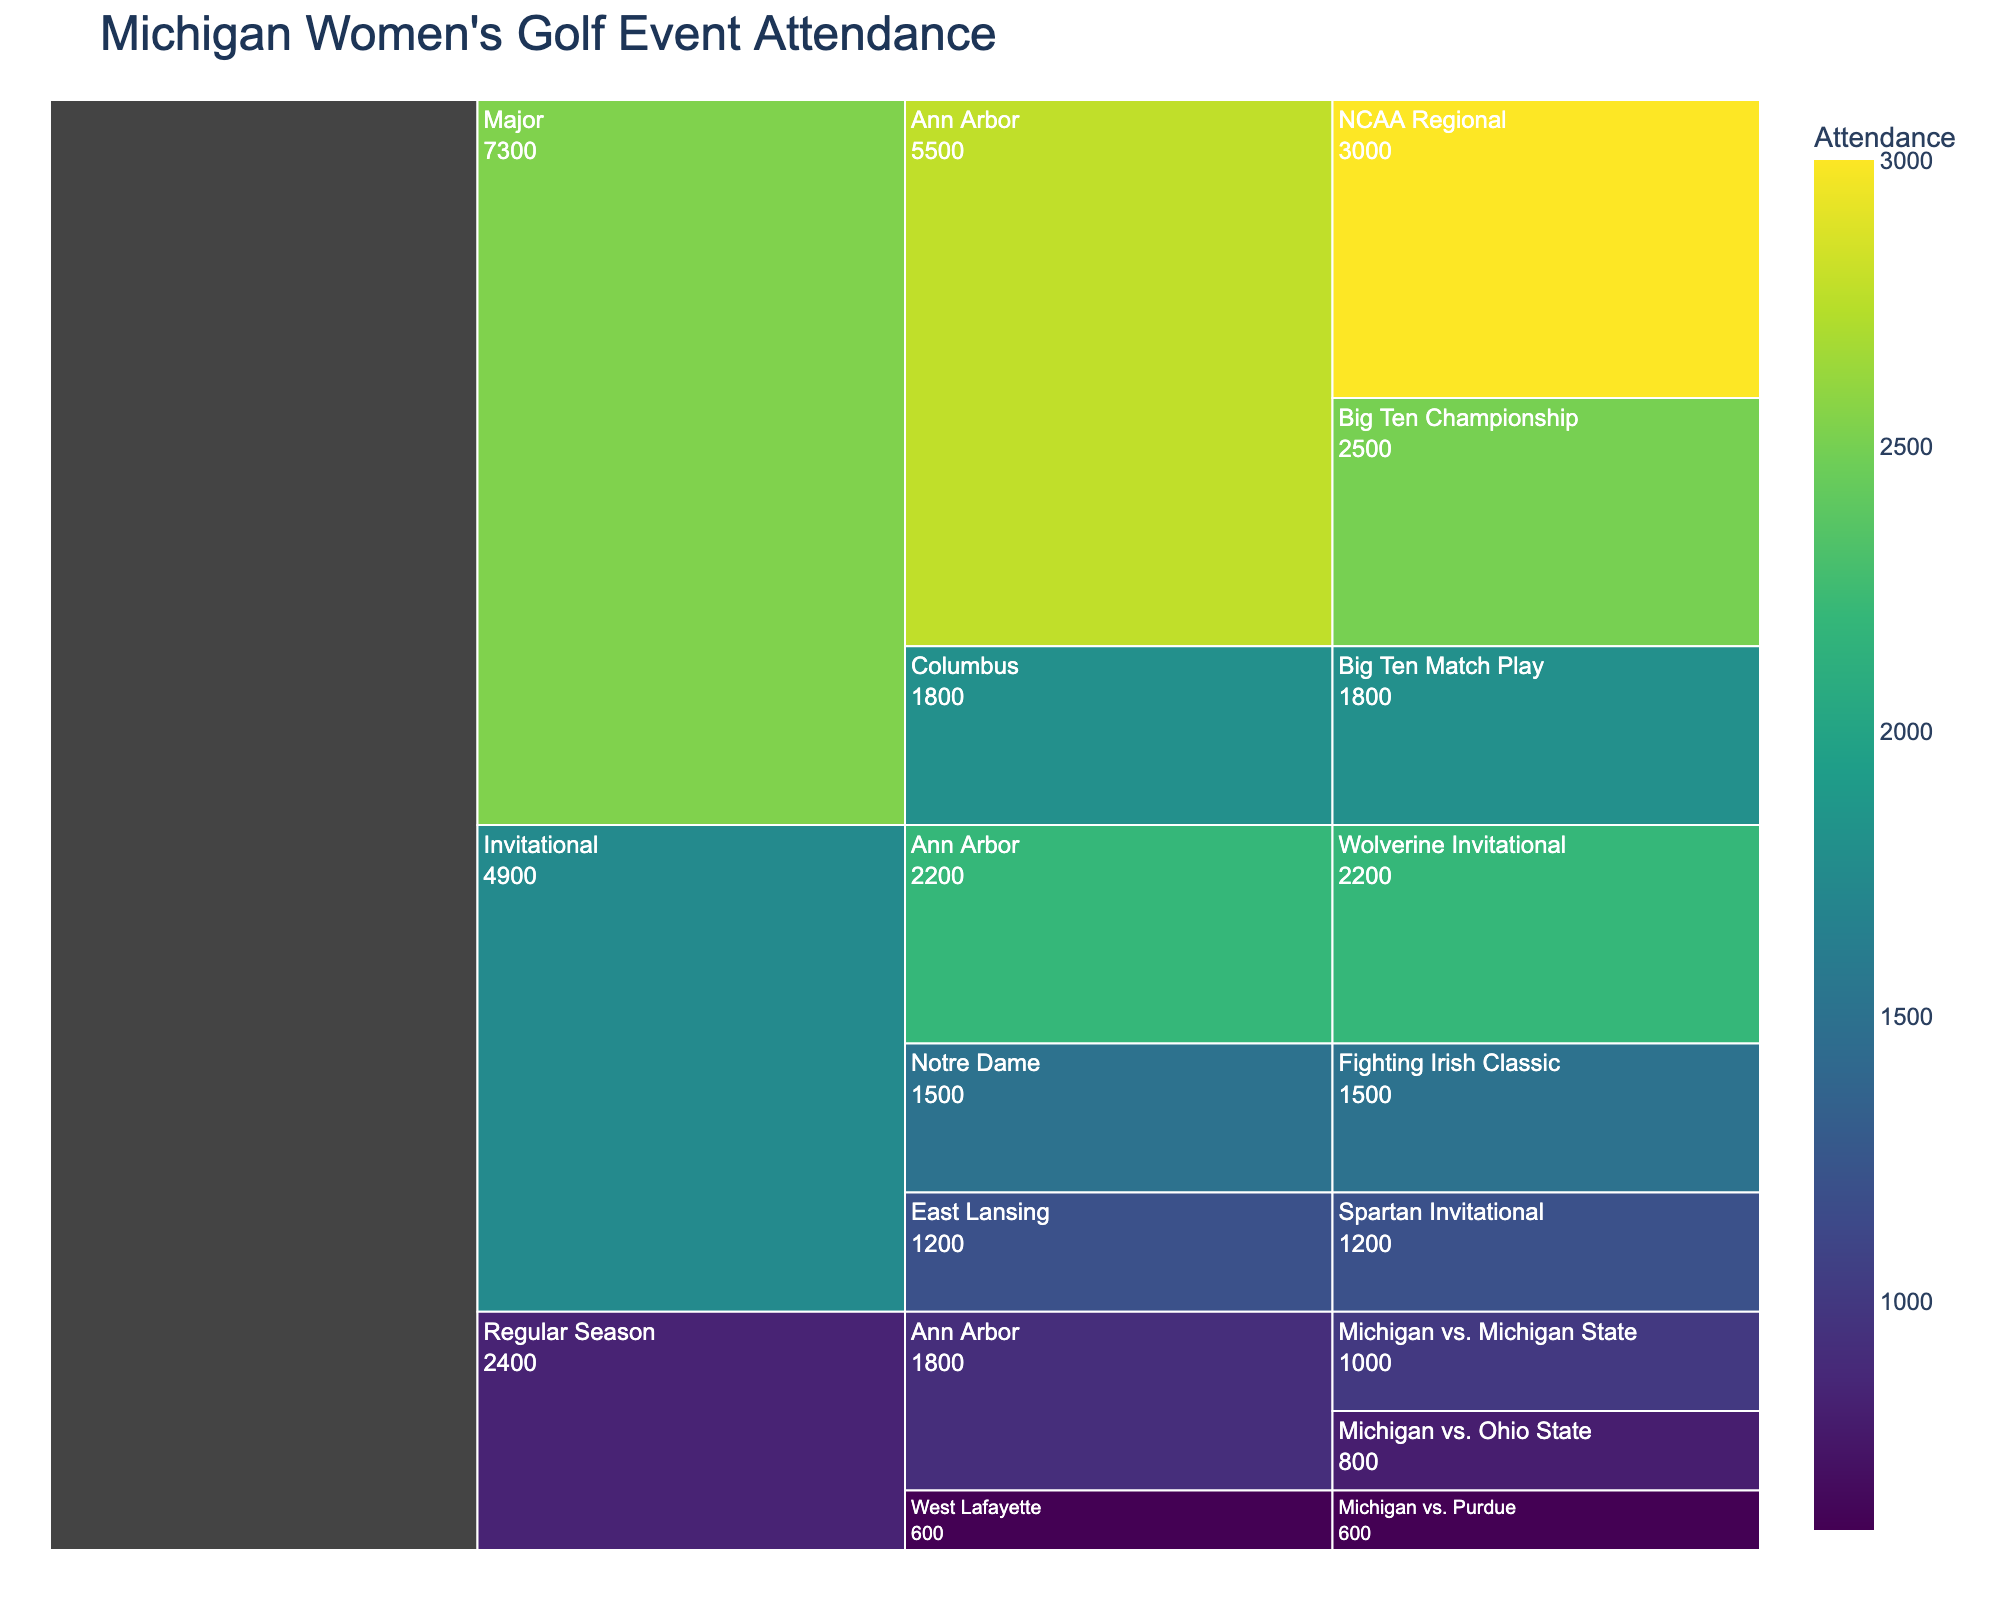What is the title of the chart? The title is displayed at the top of the chart and usually indicates what the chart is about. In this case, it reads "Michigan Women's Golf Event Attendance."
Answer: Michigan Women's Golf Event Attendance Which tournament type had the highest overall attendance? The highest attendance figures can be observed by examining the values associated with each tournament type. "Major" has the highest combined values.
Answer: Major What was the attendance for the NCAA Regional event in Ann Arbor? Find the event "NCAA Regional" under the location "Ann Arbor" and read its attendance value, which is 3000.
Answer: 3000 Which location had the most events? Count the number of events listed under each location. Ann Arbor contains the most events.
Answer: Ann Arbor By how much does the attendance for the Big Ten Championship exceed the Michigan vs. Michigan State regular season match? Subtract the attendance of Michigan vs. Michigan State match (1000) from the Big Ten Championship (2500). This gives 2500 - 1000.
Answer: 1500 Compare the attendance of Major events in Ann Arbor with those in other locations. Sum the Ann Arbor events (Big Ten Championship: 2500, NCAA Regional: 3000) which equals 5500. The attendance for Major events in other locations is Big Ten Match Play in Columbus (1800). Clearly, 5500 > 1800.
Answer: Ann Arbor had higher attendance What is the average attendance of Invitational events? Sum the attendances of all Invitational events (1200 + 1500 + 2200 = 4900) and divide by the number of events (3) to get 4900 / 3 = 1633.33.
Answer: 1633.33 Which Invitational event had higher attendance, the Spartan Invitational or the Fighting Irish Classic? Compare the attendance values of Spartan Invitational (1200) and Fighting Irish Classic (1500). 1500 > 1200.
Answer: Fighting Irish Classic Rank the Regular Season events by attendance from highest to lowest. Compare the attendance values of Michigan vs. Ohio State (800), Michigan vs. Michigan State (1000), and Michigan vs. Purdue (600). The order is Michigan vs. Michigan State (1000), Michigan vs. Ohio State (800), Michigan vs. Purdue (600).
Answer: Michigan vs. Michigan State, Michigan vs. Ohio State, Michigan vs. Purdue 